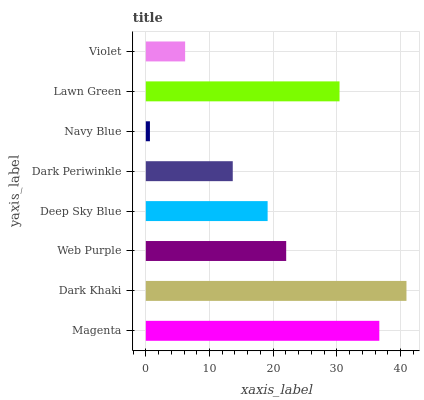Is Navy Blue the minimum?
Answer yes or no. Yes. Is Dark Khaki the maximum?
Answer yes or no. Yes. Is Web Purple the minimum?
Answer yes or no. No. Is Web Purple the maximum?
Answer yes or no. No. Is Dark Khaki greater than Web Purple?
Answer yes or no. Yes. Is Web Purple less than Dark Khaki?
Answer yes or no. Yes. Is Web Purple greater than Dark Khaki?
Answer yes or no. No. Is Dark Khaki less than Web Purple?
Answer yes or no. No. Is Web Purple the high median?
Answer yes or no. Yes. Is Deep Sky Blue the low median?
Answer yes or no. Yes. Is Dark Khaki the high median?
Answer yes or no. No. Is Navy Blue the low median?
Answer yes or no. No. 